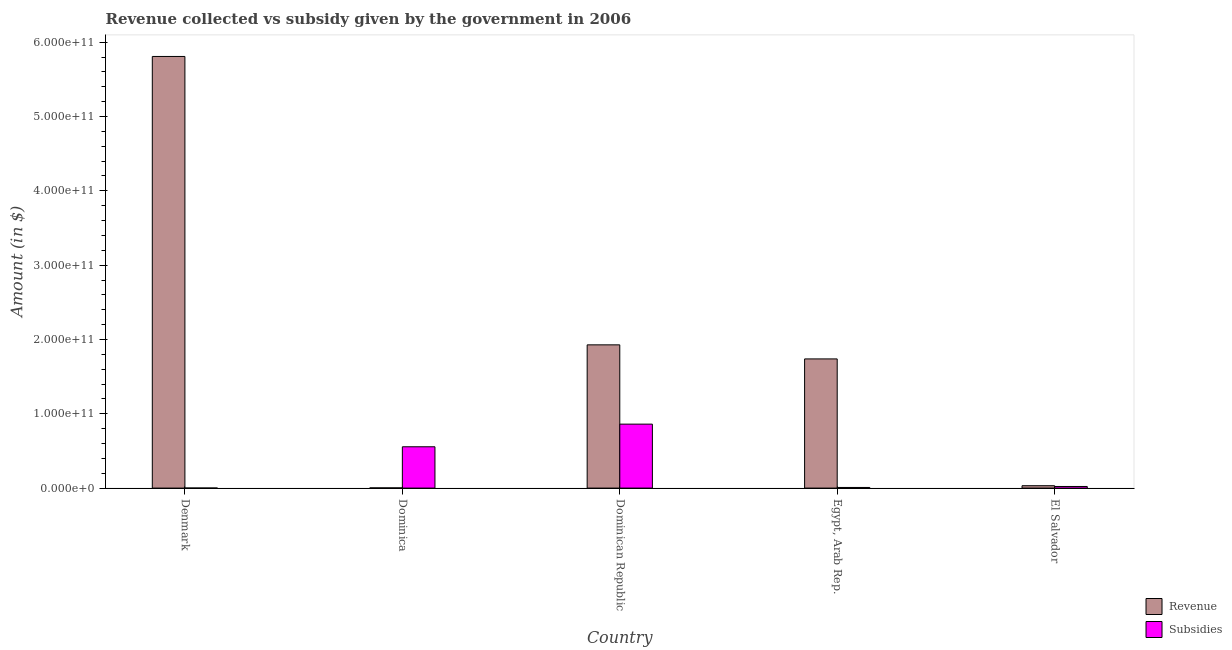Are the number of bars per tick equal to the number of legend labels?
Your answer should be compact. Yes. Are the number of bars on each tick of the X-axis equal?
Ensure brevity in your answer.  Yes. How many bars are there on the 2nd tick from the right?
Provide a succinct answer. 2. What is the label of the 3rd group of bars from the left?
Provide a succinct answer. Dominican Republic. What is the amount of subsidies given in Dominican Republic?
Keep it short and to the point. 8.61e+1. Across all countries, what is the maximum amount of revenue collected?
Make the answer very short. 5.81e+11. Across all countries, what is the minimum amount of revenue collected?
Your response must be concise. 2.69e+08. In which country was the amount of subsidies given maximum?
Your answer should be compact. Dominican Republic. In which country was the amount of revenue collected minimum?
Give a very brief answer. Dominica. What is the total amount of revenue collected in the graph?
Keep it short and to the point. 9.51e+11. What is the difference between the amount of subsidies given in Denmark and that in El Salvador?
Keep it short and to the point. -2.11e+09. What is the difference between the amount of revenue collected in Dominica and the amount of subsidies given in Dominican Republic?
Keep it short and to the point. -8.58e+1. What is the average amount of subsidies given per country?
Your answer should be very brief. 2.89e+1. What is the difference between the amount of subsidies given and amount of revenue collected in El Salvador?
Offer a very short reply. -1.04e+09. What is the ratio of the amount of subsidies given in Denmark to that in Egypt, Arab Rep.?
Keep it short and to the point. 0.06. Is the amount of revenue collected in Dominica less than that in Egypt, Arab Rep.?
Give a very brief answer. Yes. Is the difference between the amount of revenue collected in Denmark and El Salvador greater than the difference between the amount of subsidies given in Denmark and El Salvador?
Your response must be concise. Yes. What is the difference between the highest and the second highest amount of subsidies given?
Keep it short and to the point. 3.05e+1. What is the difference between the highest and the lowest amount of revenue collected?
Your answer should be compact. 5.81e+11. In how many countries, is the amount of revenue collected greater than the average amount of revenue collected taken over all countries?
Your response must be concise. 2. What does the 2nd bar from the left in Denmark represents?
Keep it short and to the point. Subsidies. What does the 2nd bar from the right in Egypt, Arab Rep. represents?
Your answer should be very brief. Revenue. How many bars are there?
Your answer should be compact. 10. Are all the bars in the graph horizontal?
Your answer should be very brief. No. What is the difference between two consecutive major ticks on the Y-axis?
Your response must be concise. 1.00e+11. Does the graph contain any zero values?
Your response must be concise. No. Does the graph contain grids?
Your response must be concise. No. What is the title of the graph?
Offer a very short reply. Revenue collected vs subsidy given by the government in 2006. What is the label or title of the X-axis?
Offer a terse response. Country. What is the label or title of the Y-axis?
Provide a short and direct response. Amount (in $). What is the Amount (in $) in Revenue in Denmark?
Provide a short and direct response. 5.81e+11. What is the Amount (in $) in Subsidies in Denmark?
Provide a succinct answer. 5.33e+07. What is the Amount (in $) in Revenue in Dominica?
Make the answer very short. 2.69e+08. What is the Amount (in $) of Subsidies in Dominica?
Give a very brief answer. 5.56e+1. What is the Amount (in $) of Revenue in Dominican Republic?
Keep it short and to the point. 1.93e+11. What is the Amount (in $) in Subsidies in Dominican Republic?
Provide a succinct answer. 8.61e+1. What is the Amount (in $) in Revenue in Egypt, Arab Rep.?
Your answer should be very brief. 1.74e+11. What is the Amount (in $) in Subsidies in Egypt, Arab Rep.?
Offer a terse response. 8.40e+08. What is the Amount (in $) of Revenue in El Salvador?
Give a very brief answer. 3.21e+09. What is the Amount (in $) in Subsidies in El Salvador?
Make the answer very short. 2.17e+09. Across all countries, what is the maximum Amount (in $) in Revenue?
Your response must be concise. 5.81e+11. Across all countries, what is the maximum Amount (in $) of Subsidies?
Offer a terse response. 8.61e+1. Across all countries, what is the minimum Amount (in $) in Revenue?
Offer a very short reply. 2.69e+08. Across all countries, what is the minimum Amount (in $) of Subsidies?
Offer a terse response. 5.33e+07. What is the total Amount (in $) of Revenue in the graph?
Ensure brevity in your answer.  9.51e+11. What is the total Amount (in $) in Subsidies in the graph?
Provide a short and direct response. 1.45e+11. What is the difference between the Amount (in $) of Revenue in Denmark and that in Dominica?
Your response must be concise. 5.81e+11. What is the difference between the Amount (in $) in Subsidies in Denmark and that in Dominica?
Make the answer very short. -5.55e+1. What is the difference between the Amount (in $) of Revenue in Denmark and that in Dominican Republic?
Keep it short and to the point. 3.88e+11. What is the difference between the Amount (in $) in Subsidies in Denmark and that in Dominican Republic?
Ensure brevity in your answer.  -8.60e+1. What is the difference between the Amount (in $) of Revenue in Denmark and that in Egypt, Arab Rep.?
Keep it short and to the point. 4.07e+11. What is the difference between the Amount (in $) in Subsidies in Denmark and that in Egypt, Arab Rep.?
Provide a succinct answer. -7.86e+08. What is the difference between the Amount (in $) of Revenue in Denmark and that in El Salvador?
Your answer should be very brief. 5.78e+11. What is the difference between the Amount (in $) of Subsidies in Denmark and that in El Salvador?
Provide a succinct answer. -2.11e+09. What is the difference between the Amount (in $) in Revenue in Dominica and that in Dominican Republic?
Provide a succinct answer. -1.92e+11. What is the difference between the Amount (in $) in Subsidies in Dominica and that in Dominican Republic?
Make the answer very short. -3.05e+1. What is the difference between the Amount (in $) of Revenue in Dominica and that in Egypt, Arab Rep.?
Offer a terse response. -1.74e+11. What is the difference between the Amount (in $) of Subsidies in Dominica and that in Egypt, Arab Rep.?
Your answer should be very brief. 5.48e+1. What is the difference between the Amount (in $) of Revenue in Dominica and that in El Salvador?
Your response must be concise. -2.94e+09. What is the difference between the Amount (in $) in Subsidies in Dominica and that in El Salvador?
Your response must be concise. 5.34e+1. What is the difference between the Amount (in $) of Revenue in Dominican Republic and that in Egypt, Arab Rep.?
Ensure brevity in your answer.  1.89e+1. What is the difference between the Amount (in $) of Subsidies in Dominican Republic and that in Egypt, Arab Rep.?
Your answer should be compact. 8.52e+1. What is the difference between the Amount (in $) of Revenue in Dominican Republic and that in El Salvador?
Ensure brevity in your answer.  1.90e+11. What is the difference between the Amount (in $) in Subsidies in Dominican Republic and that in El Salvador?
Your response must be concise. 8.39e+1. What is the difference between the Amount (in $) of Revenue in Egypt, Arab Rep. and that in El Salvador?
Your answer should be very brief. 1.71e+11. What is the difference between the Amount (in $) in Subsidies in Egypt, Arab Rep. and that in El Salvador?
Your answer should be compact. -1.33e+09. What is the difference between the Amount (in $) in Revenue in Denmark and the Amount (in $) in Subsidies in Dominica?
Offer a terse response. 5.25e+11. What is the difference between the Amount (in $) in Revenue in Denmark and the Amount (in $) in Subsidies in Dominican Republic?
Your answer should be compact. 4.95e+11. What is the difference between the Amount (in $) of Revenue in Denmark and the Amount (in $) of Subsidies in Egypt, Arab Rep.?
Ensure brevity in your answer.  5.80e+11. What is the difference between the Amount (in $) in Revenue in Denmark and the Amount (in $) in Subsidies in El Salvador?
Keep it short and to the point. 5.79e+11. What is the difference between the Amount (in $) in Revenue in Dominica and the Amount (in $) in Subsidies in Dominican Republic?
Keep it short and to the point. -8.58e+1. What is the difference between the Amount (in $) in Revenue in Dominica and the Amount (in $) in Subsidies in Egypt, Arab Rep.?
Your response must be concise. -5.70e+08. What is the difference between the Amount (in $) of Revenue in Dominica and the Amount (in $) of Subsidies in El Salvador?
Your response must be concise. -1.90e+09. What is the difference between the Amount (in $) in Revenue in Dominican Republic and the Amount (in $) in Subsidies in Egypt, Arab Rep.?
Provide a short and direct response. 1.92e+11. What is the difference between the Amount (in $) of Revenue in Dominican Republic and the Amount (in $) of Subsidies in El Salvador?
Offer a very short reply. 1.91e+11. What is the difference between the Amount (in $) of Revenue in Egypt, Arab Rep. and the Amount (in $) of Subsidies in El Salvador?
Ensure brevity in your answer.  1.72e+11. What is the average Amount (in $) of Revenue per country?
Your response must be concise. 1.90e+11. What is the average Amount (in $) of Subsidies per country?
Offer a very short reply. 2.89e+1. What is the difference between the Amount (in $) in Revenue and Amount (in $) in Subsidies in Denmark?
Offer a terse response. 5.81e+11. What is the difference between the Amount (in $) in Revenue and Amount (in $) in Subsidies in Dominica?
Offer a terse response. -5.53e+1. What is the difference between the Amount (in $) of Revenue and Amount (in $) of Subsidies in Dominican Republic?
Ensure brevity in your answer.  1.07e+11. What is the difference between the Amount (in $) of Revenue and Amount (in $) of Subsidies in Egypt, Arab Rep.?
Offer a very short reply. 1.73e+11. What is the difference between the Amount (in $) of Revenue and Amount (in $) of Subsidies in El Salvador?
Offer a terse response. 1.04e+09. What is the ratio of the Amount (in $) in Revenue in Denmark to that in Dominica?
Provide a succinct answer. 2158.34. What is the ratio of the Amount (in $) in Subsidies in Denmark to that in Dominica?
Make the answer very short. 0. What is the ratio of the Amount (in $) of Revenue in Denmark to that in Dominican Republic?
Ensure brevity in your answer.  3.01. What is the ratio of the Amount (in $) of Subsidies in Denmark to that in Dominican Republic?
Provide a succinct answer. 0. What is the ratio of the Amount (in $) in Revenue in Denmark to that in Egypt, Arab Rep.?
Ensure brevity in your answer.  3.34. What is the ratio of the Amount (in $) of Subsidies in Denmark to that in Egypt, Arab Rep.?
Offer a very short reply. 0.06. What is the ratio of the Amount (in $) of Revenue in Denmark to that in El Salvador?
Provide a succinct answer. 180.93. What is the ratio of the Amount (in $) in Subsidies in Denmark to that in El Salvador?
Your answer should be compact. 0.02. What is the ratio of the Amount (in $) in Revenue in Dominica to that in Dominican Republic?
Offer a terse response. 0. What is the ratio of the Amount (in $) in Subsidies in Dominica to that in Dominican Republic?
Provide a succinct answer. 0.65. What is the ratio of the Amount (in $) of Revenue in Dominica to that in Egypt, Arab Rep.?
Offer a very short reply. 0. What is the ratio of the Amount (in $) in Subsidies in Dominica to that in Egypt, Arab Rep.?
Your response must be concise. 66.22. What is the ratio of the Amount (in $) of Revenue in Dominica to that in El Salvador?
Make the answer very short. 0.08. What is the ratio of the Amount (in $) of Subsidies in Dominica to that in El Salvador?
Make the answer very short. 25.66. What is the ratio of the Amount (in $) of Revenue in Dominican Republic to that in Egypt, Arab Rep.?
Provide a short and direct response. 1.11. What is the ratio of the Amount (in $) of Subsidies in Dominican Republic to that in Egypt, Arab Rep.?
Offer a very short reply. 102.51. What is the ratio of the Amount (in $) of Revenue in Dominican Republic to that in El Salvador?
Provide a short and direct response. 60.04. What is the ratio of the Amount (in $) of Subsidies in Dominican Republic to that in El Salvador?
Your answer should be compact. 39.71. What is the ratio of the Amount (in $) in Revenue in Egypt, Arab Rep. to that in El Salvador?
Offer a terse response. 54.14. What is the ratio of the Amount (in $) in Subsidies in Egypt, Arab Rep. to that in El Salvador?
Ensure brevity in your answer.  0.39. What is the difference between the highest and the second highest Amount (in $) in Revenue?
Ensure brevity in your answer.  3.88e+11. What is the difference between the highest and the second highest Amount (in $) of Subsidies?
Give a very brief answer. 3.05e+1. What is the difference between the highest and the lowest Amount (in $) in Revenue?
Ensure brevity in your answer.  5.81e+11. What is the difference between the highest and the lowest Amount (in $) in Subsidies?
Provide a succinct answer. 8.60e+1. 